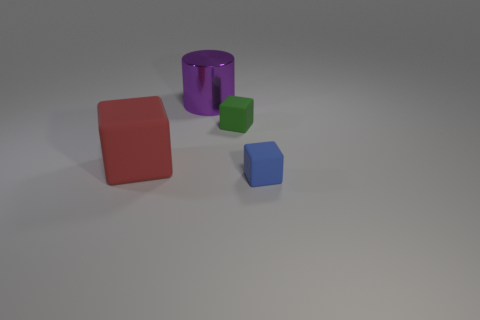Add 2 metal cylinders. How many objects exist? 6 Subtract all cylinders. How many objects are left? 3 Add 2 large purple shiny objects. How many large purple shiny objects are left? 3 Add 1 small purple cylinders. How many small purple cylinders exist? 1 Subtract 0 yellow blocks. How many objects are left? 4 Subtract all gray shiny balls. Subtract all big cubes. How many objects are left? 3 